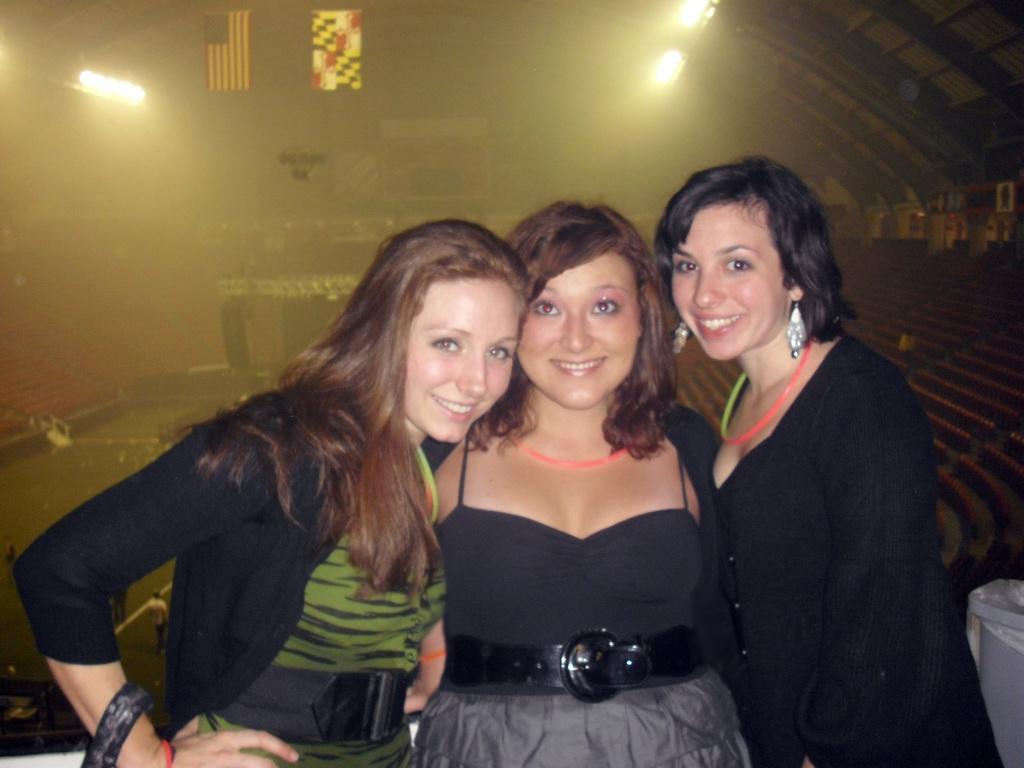Can you describe this image briefly? In this image I can see three women wearing black and green colored dresses are standing and smiling. In the background I can see number of chairs in the stadium, the ceiling of the stadium, new lights to the ceiling, two flags, the ground and a person is standing on the ground. 